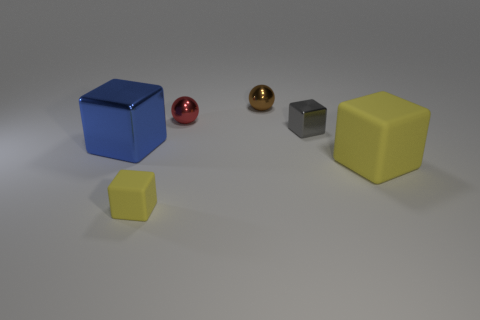What size is the block that is the same color as the small rubber object?
Your answer should be very brief. Large. There is another metal object that is the same shape as the large blue object; what color is it?
Your answer should be very brief. Gray. Is there anything else that is the same color as the small metallic cube?
Offer a very short reply. No. What number of other things are the same material as the small yellow block?
Provide a short and direct response. 1. The brown ball is what size?
Give a very brief answer. Small. Is there another thing that has the same shape as the brown metallic thing?
Keep it short and to the point. Yes. How many objects are large red cylinders or blocks to the left of the large yellow object?
Provide a short and direct response. 3. What is the color of the metal thing that is to the right of the brown ball?
Offer a very short reply. Gray. There is a metal object that is on the left side of the small red ball; is its size the same as the yellow rubber block that is left of the red thing?
Ensure brevity in your answer.  No. Is there a purple metal cylinder that has the same size as the red sphere?
Keep it short and to the point. No. 